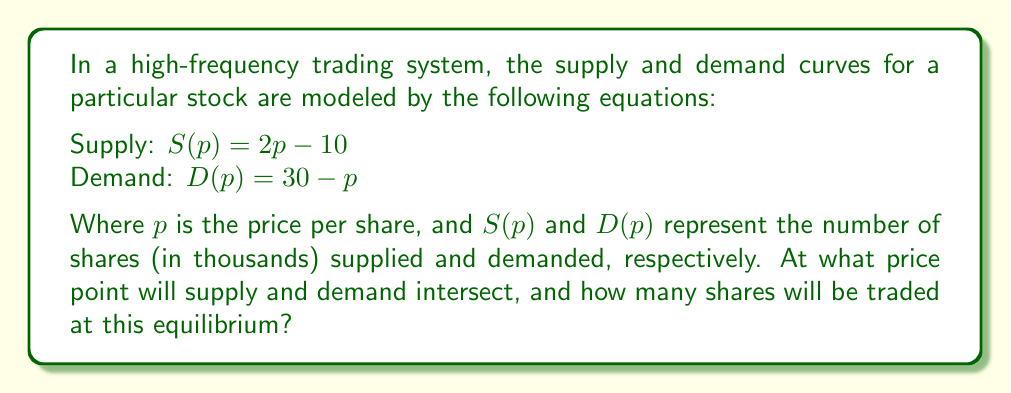Show me your answer to this math problem. To find the intersection point of the supply and demand curves, we need to solve the equation where supply equals demand:

1) Set up the equation:
   $S(p) = D(p)$
   $2p - 10 = 30 - p$

2) Solve for $p$:
   $2p - 10 = 30 - p$
   $2p + p = 30 + 10$
   $3p = 40$
   $p = \frac{40}{3} \approx 13.33$

3) Calculate the quantity at equilibrium by substituting $p = \frac{40}{3}$ into either the supply or demand equation:
   $S(\frac{40}{3}) = 2(\frac{40}{3}) - 10 = \frac{80}{3} - 10 = \frac{80}{3} - \frac{30}{3} = \frac{50}{3} \approx 16.67$

Therefore, the equilibrium price is $\frac{40}{3}$ dollars per share, and the quantity traded at equilibrium is $\frac{50}{3}$ thousand shares.
Answer: Price: $\frac{40}{3}$, Quantity: $\frac{50}{3}$ (in thousands of shares) 